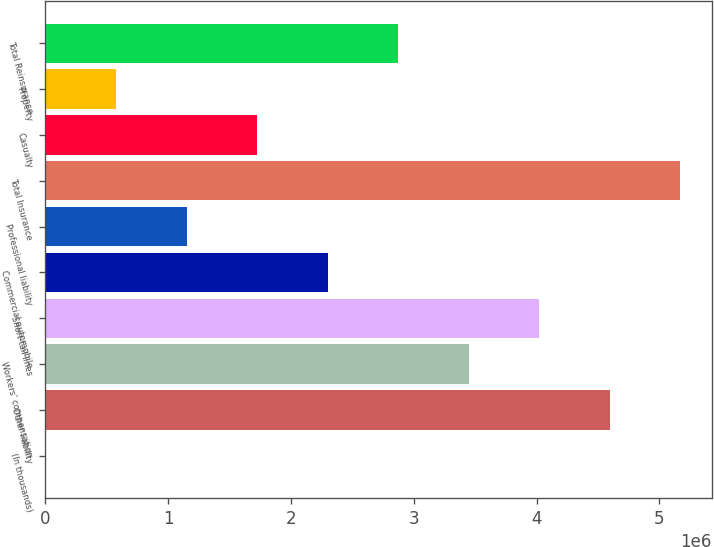<chart> <loc_0><loc_0><loc_500><loc_500><bar_chart><fcel>(In thousands)<fcel>Other liability<fcel>Workers' compensation<fcel>Short-tail lines<fcel>Commercial automobile<fcel>Professional liability<fcel>Total Insurance<fcel>Casualty<fcel>Property<fcel>Total Reinsurance<nl><fcel>2014<fcel>4.59594e+06<fcel>3.44746e+06<fcel>4.0217e+06<fcel>2.29898e+06<fcel>1.15049e+06<fcel>5.17018e+06<fcel>1.72474e+06<fcel>576254<fcel>2.87322e+06<nl></chart> 